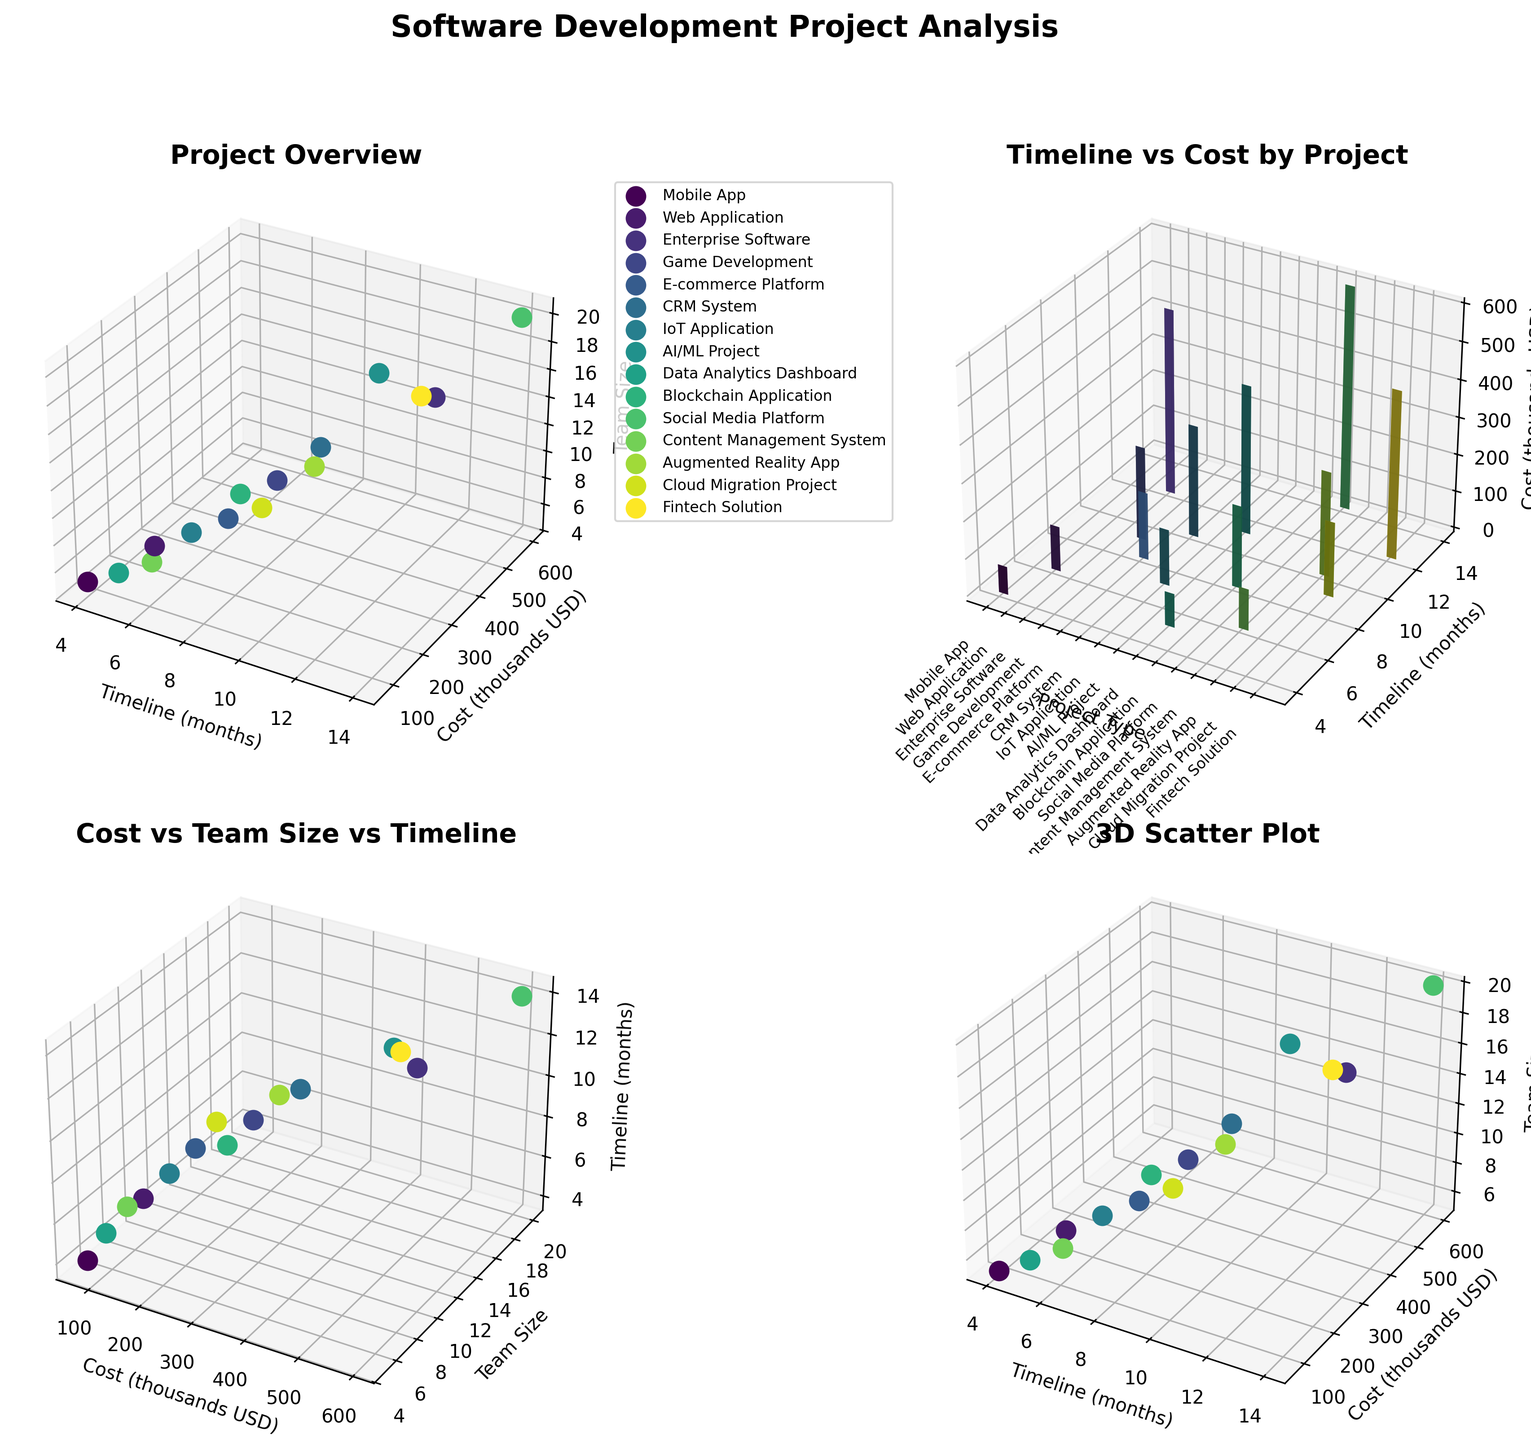What's the title of the first subplot? The title of the first subplot is positioned at the top and is clearly labeled. It provides an overview of the project data in 3D space.
Answer: Project Overview Which project type has the highest cost and what is that cost in thousands USD? By examining the scatter plot in the first subplot, we can identify that the Social Media Platform has the highest cost, which is shown on the Z-axis in thousands of USD.
Answer: Social Media Platform, 600 How many data points are there in total across all subplots? We can count the distinct markers in any of the subplots since they all represent the same data. Each subplot has 15 data points, one for each project type.
Answer: 15 Which project has the largest team size and what is the size? By looking at the scatter plot in the first subplot, we identify the data point furthest along the team size (Z-axis). It shows the Social Media Platform requires the largest team.
Answer: Social Media Platform, 20 Which project type has the longest timeline, and how long is it? Examining the X-axis in the first subplot, we see the Social Media Platform has the longest timeline at 14 months.
Answer: Social Media Platform, 14 What's the average cost (thousands USD) of projects that take more than 10 months to complete? Identify the projects with timelines over 10 months, then average their costs in thousands from the dataset. The projects are "Social Media", "AI/ML Project", "Enterprise Software", and "Fintech Solution" with costs of 600, 400, 500, and 450 thousands respectively. The average is (600 + 400 + 500 + 450) / 4.
Answer: 487.5 Which axis on the second subplot represents the project type, and how is it labeled? In the bar plot of the second subplot, the project type is represented along the X-axis. It is labeled with project names rotated for readability.
Answer: X-axis Are there more projects that take less than or equal to 8 months or more than 8 months to complete? By examining the X-axis values for timelines in the first subplot, count projects with timelines ≤8 and >8 months. Projects ≤8 months: Mobile App, Web Application, E-commerce, IoT, Blockchain, Content Management, Data Analytics (7 projects). Projects >8 months: Game Development, CRM, AR App, Cloud Migration, Social Media, Fintech, Enterprise Software, AI/ML (8 projects).
Answer: More than 8 months What's the relationship between cost and team size shown in the third subplot? Observing the scatter plot in the third subplot (Cost vs-Team Size vs-Timeline), we see that higher costs tend to associate with larger team sizes.
Answer: Higher costs, larger teams What's the total cost in thousands USD for all projects combined? Sum up the costs of each project in thousands of USD from the dataset: 75 + 120 + 500 + 250 + 180 + 300 + 150 + 400 + 90 + 220 + 600 + 110 + 280 + 200 + 450. The result is: 75 + 120 + 500 + 250 + 180 + 300 + 150 + 400 + 90 + 220 + 600 + 110 + 280 + 200 + 450 = 3925.
Answer: 3925 